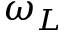<formula> <loc_0><loc_0><loc_500><loc_500>\omega _ { L }</formula> 